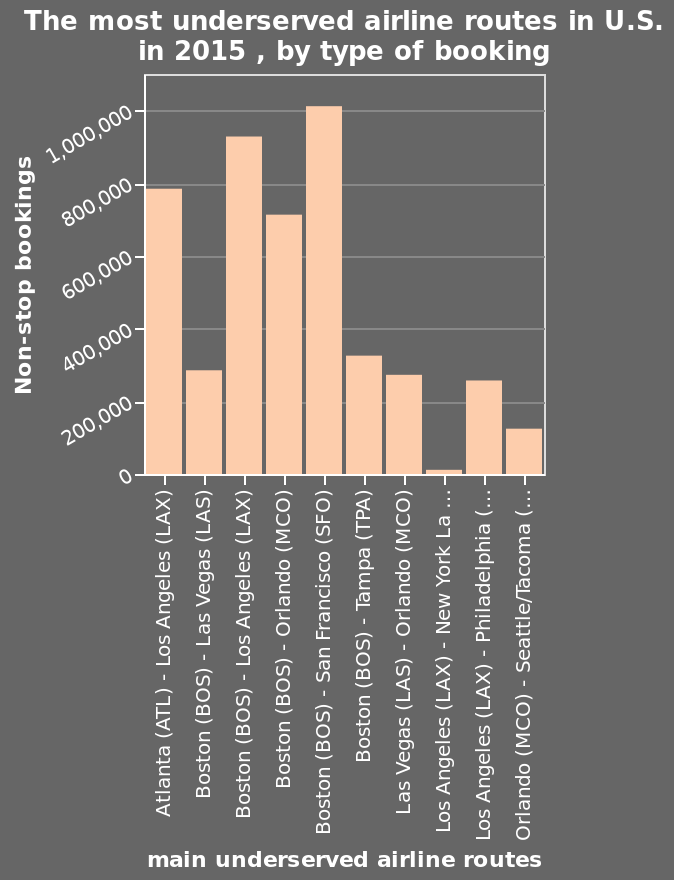<image>
please summary the statistics and relations of the chart West Coast airlines had the most non-stop bookings. New York had the least. please describe the details of the chart This is a bar plot labeled The most underserved airline routes in U.S. in 2015 , by type of booking. The x-axis shows main underserved airline routes on categorical scale with Atlanta (ATL) - Los Angeles (LAX) on one end and Orlando (MCO) - Seattle/Tacoma (SEA) at the other while the y-axis measures Non-stop bookings along linear scale of range 0 to 1,000,000. Is the size of the entertainment industry larger than the next highest industry? It is not specified in the given information. What are the main underserved airline routes in the U.S. in 2015 according to the bar plot?  The main underserved airline routes in the U.S. in 2015 according to the bar plot are Atlanta (ATL) - Los Angeles (LAX) and Orlando (MCO) - Seattle/Tacoma (SEA). 